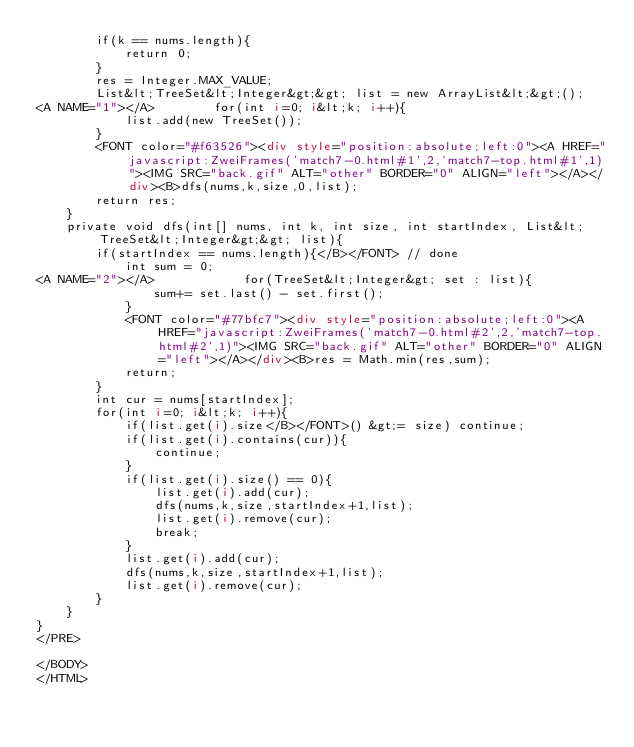<code> <loc_0><loc_0><loc_500><loc_500><_HTML_>        if(k == nums.length){
            return 0;
        }
        res = Integer.MAX_VALUE;
        List&lt;TreeSet&lt;Integer&gt;&gt; list = new ArrayList&lt;&gt;();
<A NAME="1"></A>        for(int i=0; i&lt;k; i++){
            list.add(new TreeSet());
        }
        <FONT color="#f63526"><div style="position:absolute;left:0"><A HREF="javascript:ZweiFrames('match7-0.html#1',2,'match7-top.html#1',1)"><IMG SRC="back.gif" ALT="other" BORDER="0" ALIGN="left"></A></div><B>dfs(nums,k,size,0,list);
        return res;
    }
    private void dfs(int[] nums, int k, int size, int startIndex, List&lt;TreeSet&lt;Integer&gt;&gt; list){
        if(startIndex == nums.length){</B></FONT> // done
            int sum = 0;
<A NAME="2"></A>            for(TreeSet&lt;Integer&gt; set : list){
                sum+= set.last() - set.first();
            }
            <FONT color="#77bfc7"><div style="position:absolute;left:0"><A HREF="javascript:ZweiFrames('match7-0.html#2',2,'match7-top.html#2',1)"><IMG SRC="back.gif" ALT="other" BORDER="0" ALIGN="left"></A></div><B>res = Math.min(res,sum);
            return;
        }
        int cur = nums[startIndex];
        for(int i=0; i&lt;k; i++){
            if(list.get(i).size</B></FONT>() &gt;= size) continue;
            if(list.get(i).contains(cur)){
                continue;
            }
            if(list.get(i).size() == 0){
                list.get(i).add(cur);
                dfs(nums,k,size,startIndex+1,list);
                list.get(i).remove(cur);
                break;
            }
            list.get(i).add(cur);
            dfs(nums,k,size,startIndex+1,list);
            list.get(i).remove(cur);
        }
    }
}
</PRE>

</BODY>
</HTML>
</code> 